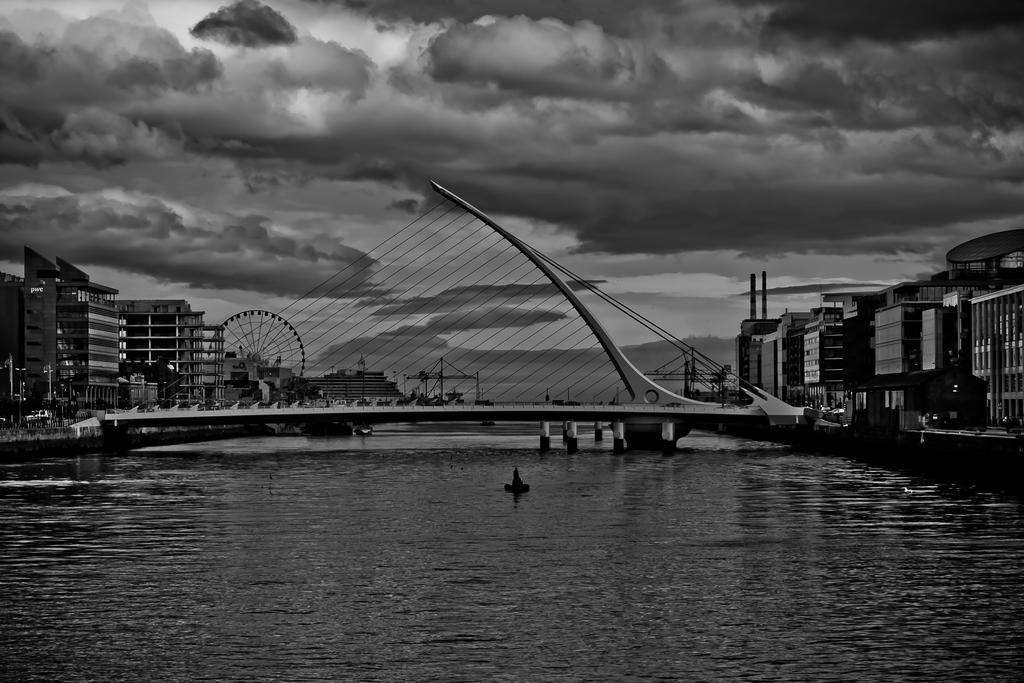In one or two sentences, can you explain what this image depicts? This is a black and white image, in this image at the bottom there is a river and in the center there is a bridge. On the right and left side there are some and buildings and houses and poles, and in the background there is a gain twill and some wires and some objects. At the top of the image there is sky. 